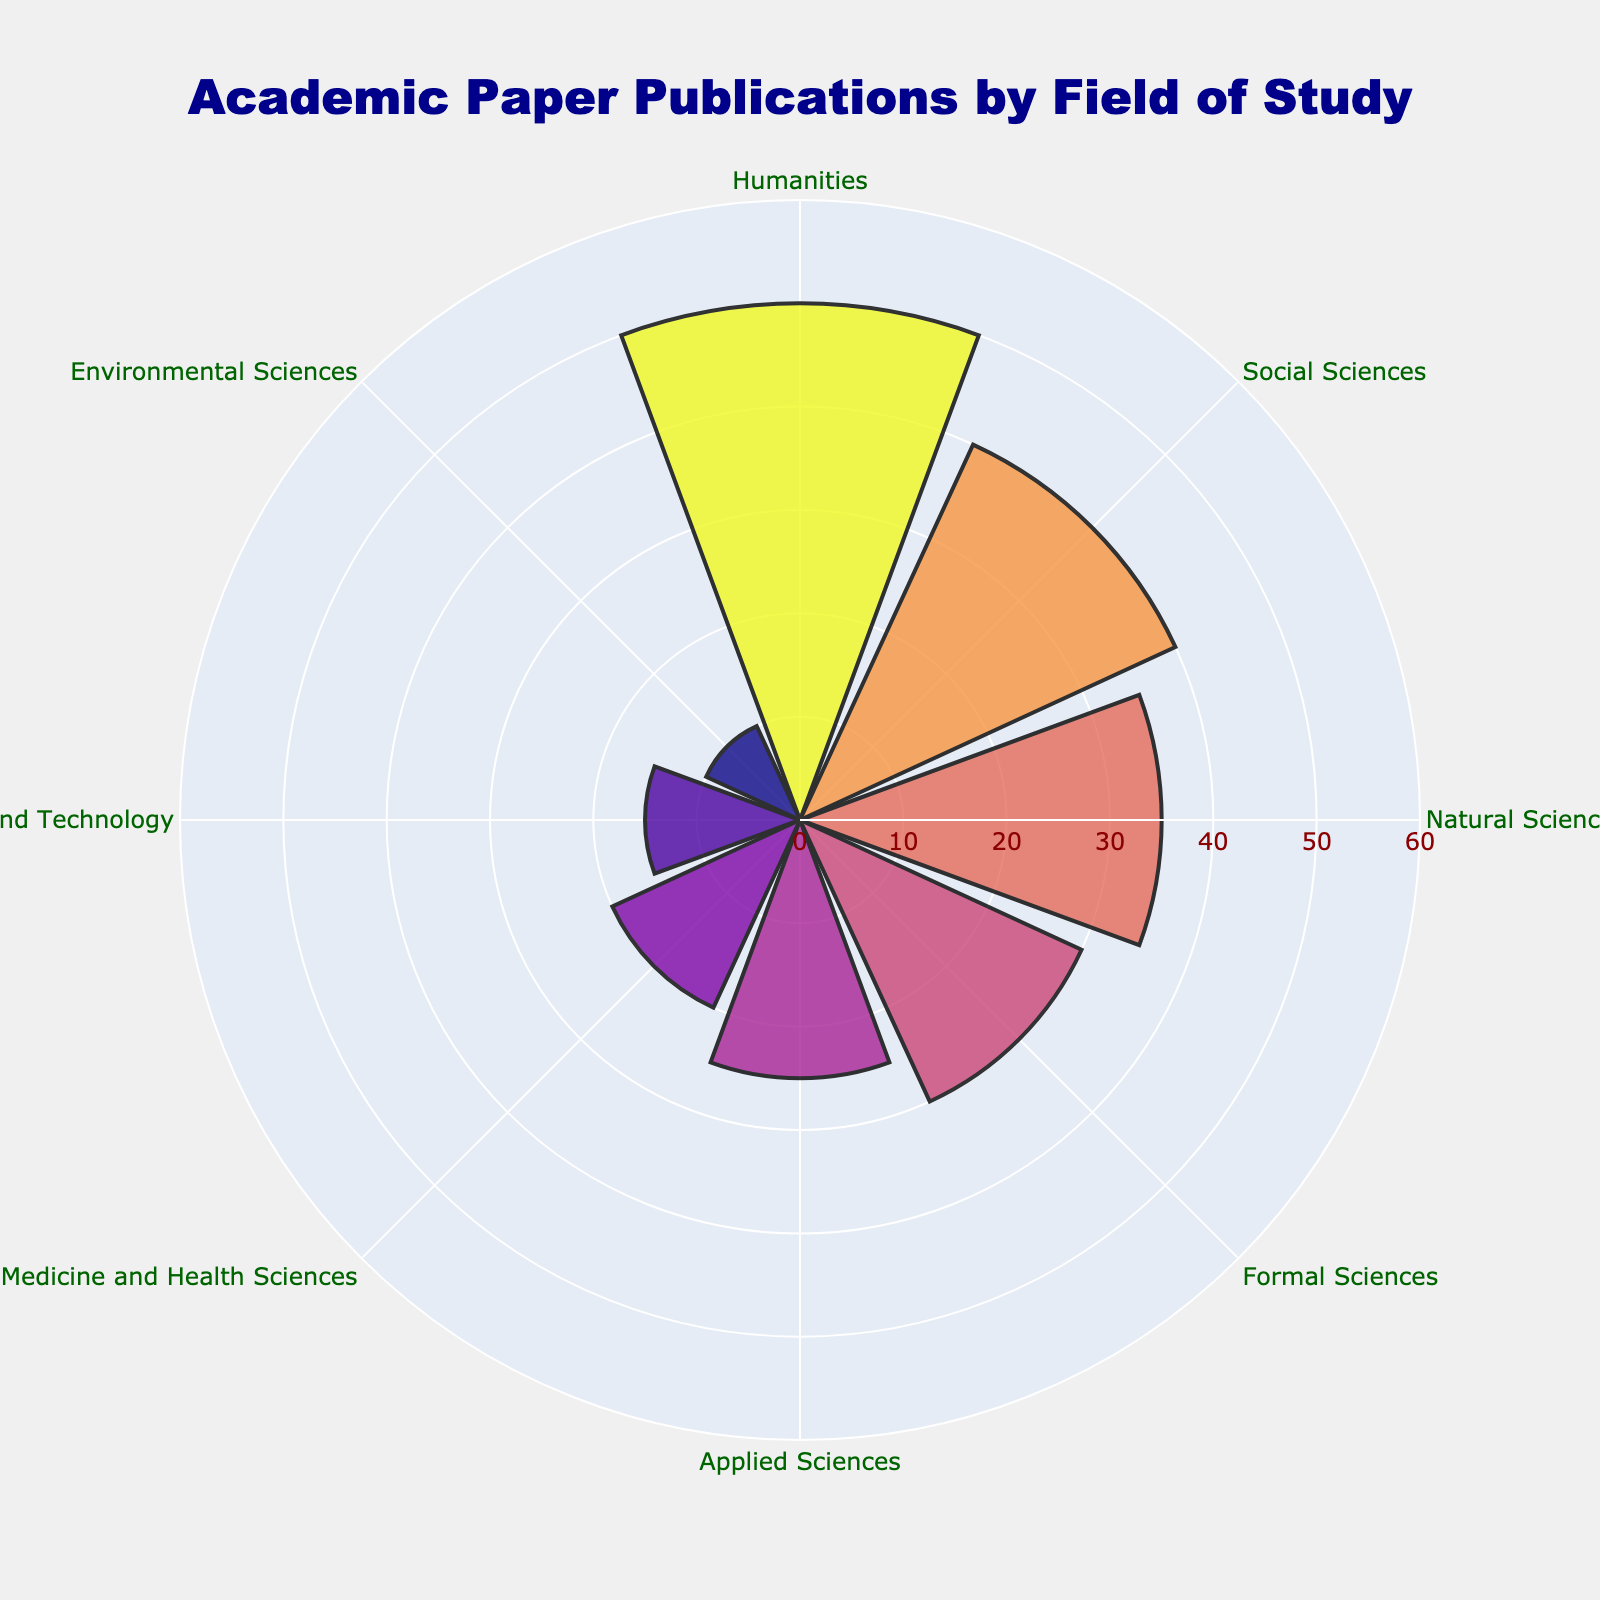What is the title of the chart? The title is often placed at the top of the chart, and here it is labeled clearly.
Answer: Academic Paper Publications by Field of Study What is the color of the highest number of publications section? By looking at the colors, the highest number of publications (which is for Humanities) will have the darkest color, as the color intensity increases with the number of publications.
Answer: Darkest color What is the range of the radial axis? The radial axis range defines how far out the plot can go, and it should be visible as labeled on the chart's radial guideline.
Answer: 0 to 60 Which field has the least number of publications? The field with the smallest radial length would represent the lowest number of publications.
Answer: Environmental Sciences What is the sum of publications in Humanities and Social Sciences? Add the number of publications in Humanities (50) and Social Sciences (40): 50 + 40 = 90.
Answer: 90 How many fields have more than 25 publications? Count the fields where the radial length (number of publications) is more than 25. These fields are Humanities, Social Sciences, Natural Sciences, and Formal Sciences.
Answer: 4 fields By how much do Humanities publications exceed Engineering and Technology publications? Subtract the number of Engineering and Technology publications (15) from the Humanities publications (50): 50 - 15 = 35.
Answer: 35 What is the average number of publications per field? Sum all publication numbers and divide by the number of fields. (50 + 40 + 35 + 30 + 25 + 20 + 15 + 10) / 8: 225 / 8 = 28.125.
Answer: 28.125 Which field is directly opposite Applied Sciences in the polar area chart? Observe the chart's circular layout. Applied Sciences is opposite Medicine and Health Sciences.
Answer: Medicine and Health Sciences What is the width of the polar area chart in pixels? Check the layout dimensions provided in the visualization details.
Answer: 800 pixels 